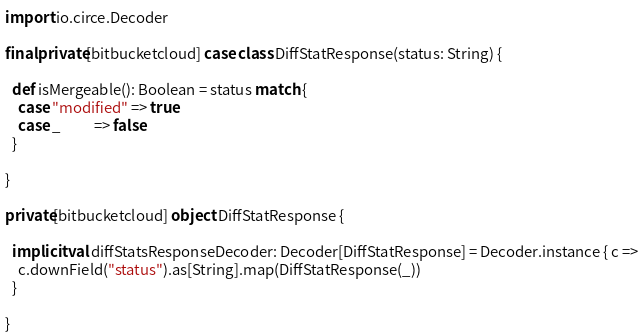<code> <loc_0><loc_0><loc_500><loc_500><_Scala_>
import io.circe.Decoder

final private[bitbucketcloud] case class DiffStatResponse(status: String) {

  def isMergeable(): Boolean = status match {
    case "modified" => true
    case _          => false
  }

}

private[bitbucketcloud] object DiffStatResponse {

  implicit val diffStatsResponseDecoder: Decoder[DiffStatResponse] = Decoder.instance { c =>
    c.downField("status").as[String].map(DiffStatResponse(_))
  }

}
</code> 